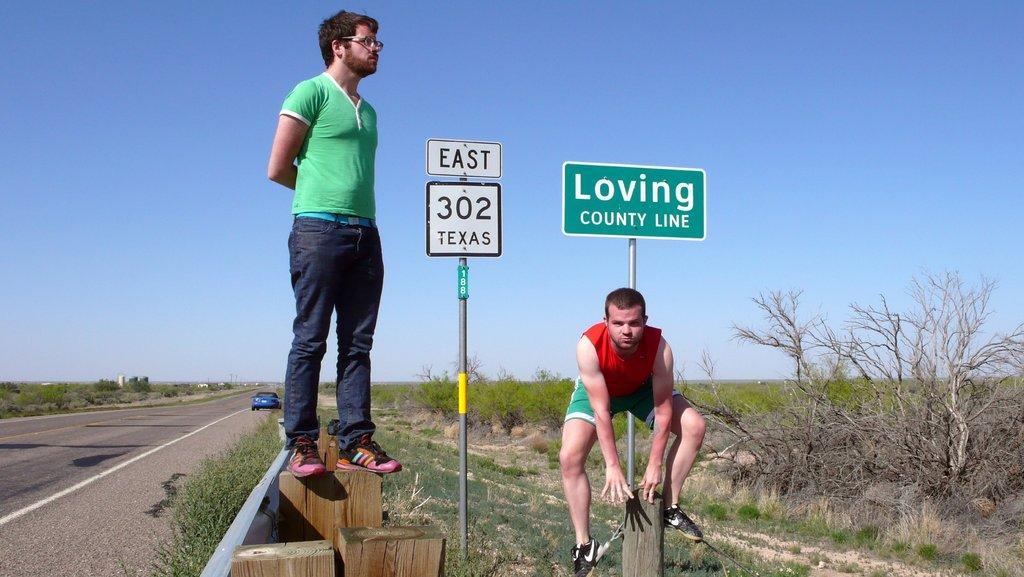Could you give a brief overview of what you see in this image? In this image, we can see some plants. There are two persons wearing clothes. There are boards in the middle of the image. There are wooden planks at the bottom of the image. There is a car on the road which is in the bottom left of the image. There is a sky at the top of the image. 